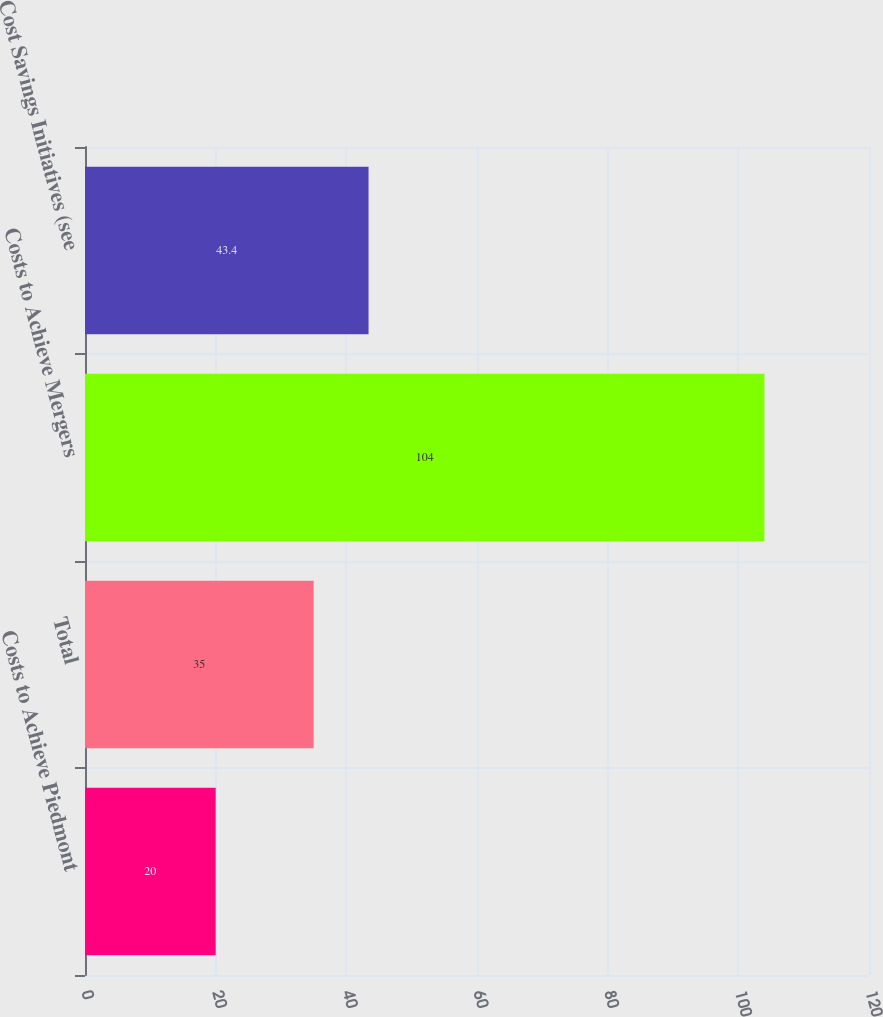Convert chart. <chart><loc_0><loc_0><loc_500><loc_500><bar_chart><fcel>Costs to Achieve Piedmont<fcel>Total<fcel>Costs to Achieve Mergers<fcel>Cost Savings Initiatives (see<nl><fcel>20<fcel>35<fcel>104<fcel>43.4<nl></chart> 